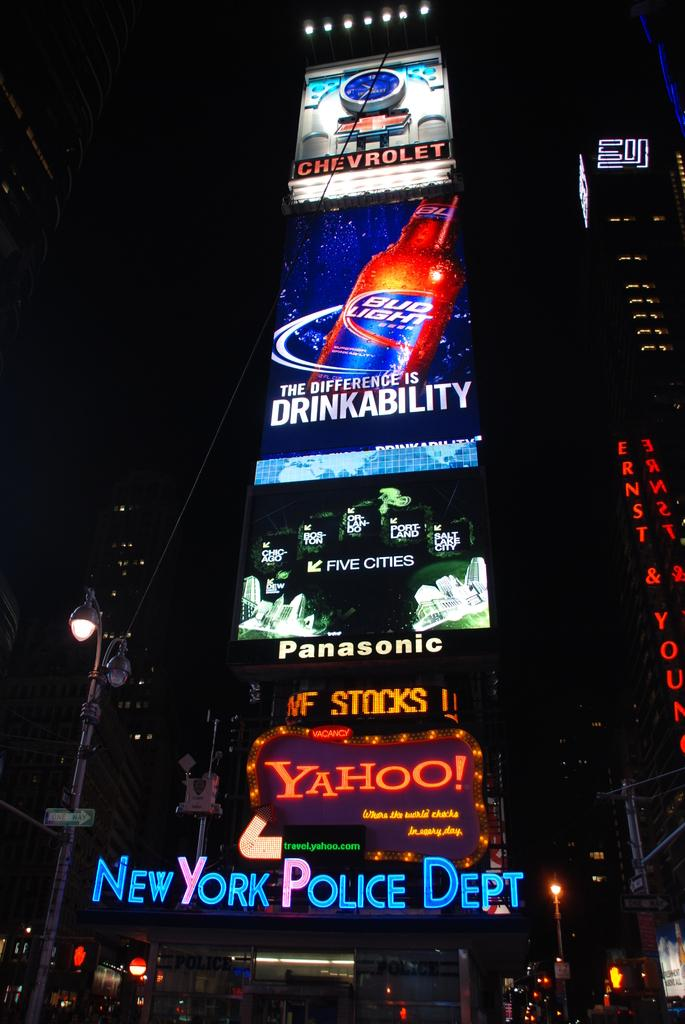<image>
Write a terse but informative summary of the picture. A variety of advertisers light up the night, including Yahoo and Panasonic. 